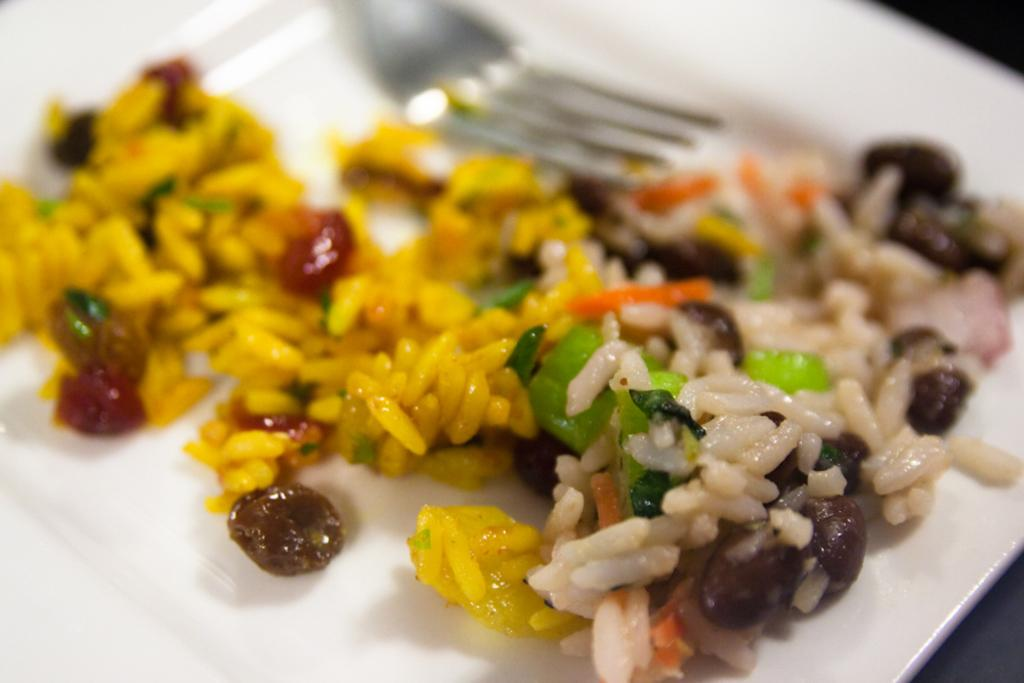What type of food item is visible in the image? There is a food item in the image, but the specific type cannot be determined from the provided facts. What utensil is present on the plate in the image? There is a fork on a plate in the image. What color is the plate in the image? The plate is white. Can you describe the background of the image? The background of the image is blurred. Can you tell me how many geese are flying in the background of the image? There are no geese present in the image; the background is blurred, but no geese can be seen. 